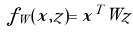Convert formula to latex. <formula><loc_0><loc_0><loc_500><loc_500>f _ { W } ( x , z ) = x ^ { T } W z</formula> 